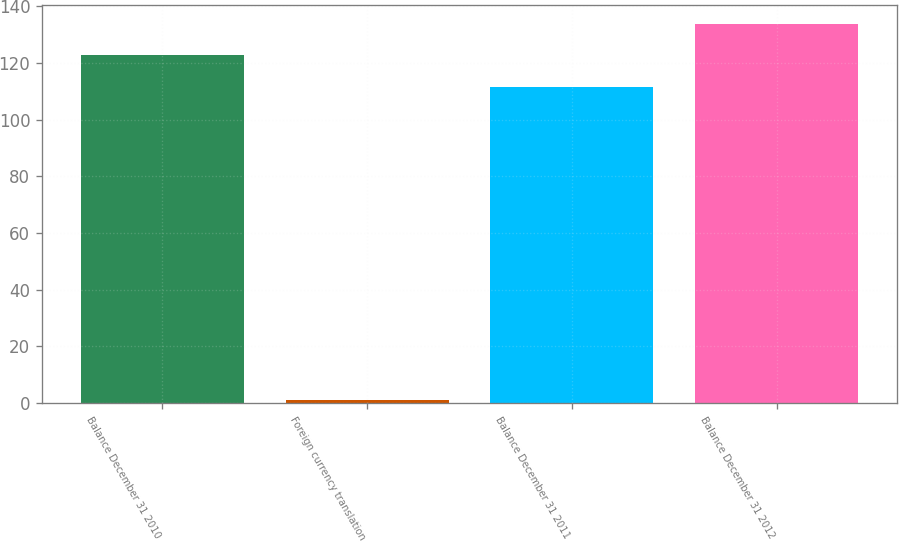Convert chart. <chart><loc_0><loc_0><loc_500><loc_500><bar_chart><fcel>Balance December 31 2010<fcel>Foreign currency translation<fcel>Balance December 31 2011<fcel>Balance December 31 2012<nl><fcel>122.65<fcel>1<fcel>111.5<fcel>133.8<nl></chart> 